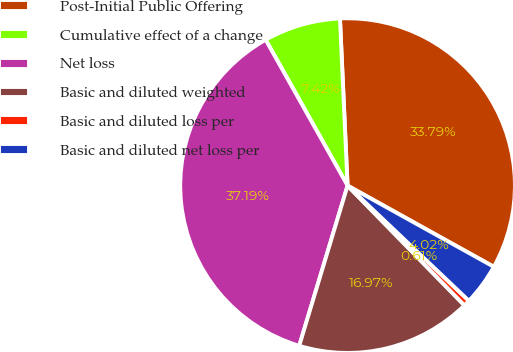<chart> <loc_0><loc_0><loc_500><loc_500><pie_chart><fcel>Post-Initial Public Offering<fcel>Cumulative effect of a change<fcel>Net loss<fcel>Basic and diluted weighted<fcel>Basic and diluted loss per<fcel>Basic and diluted net loss per<nl><fcel>33.79%<fcel>7.42%<fcel>37.19%<fcel>16.97%<fcel>0.61%<fcel>4.02%<nl></chart> 